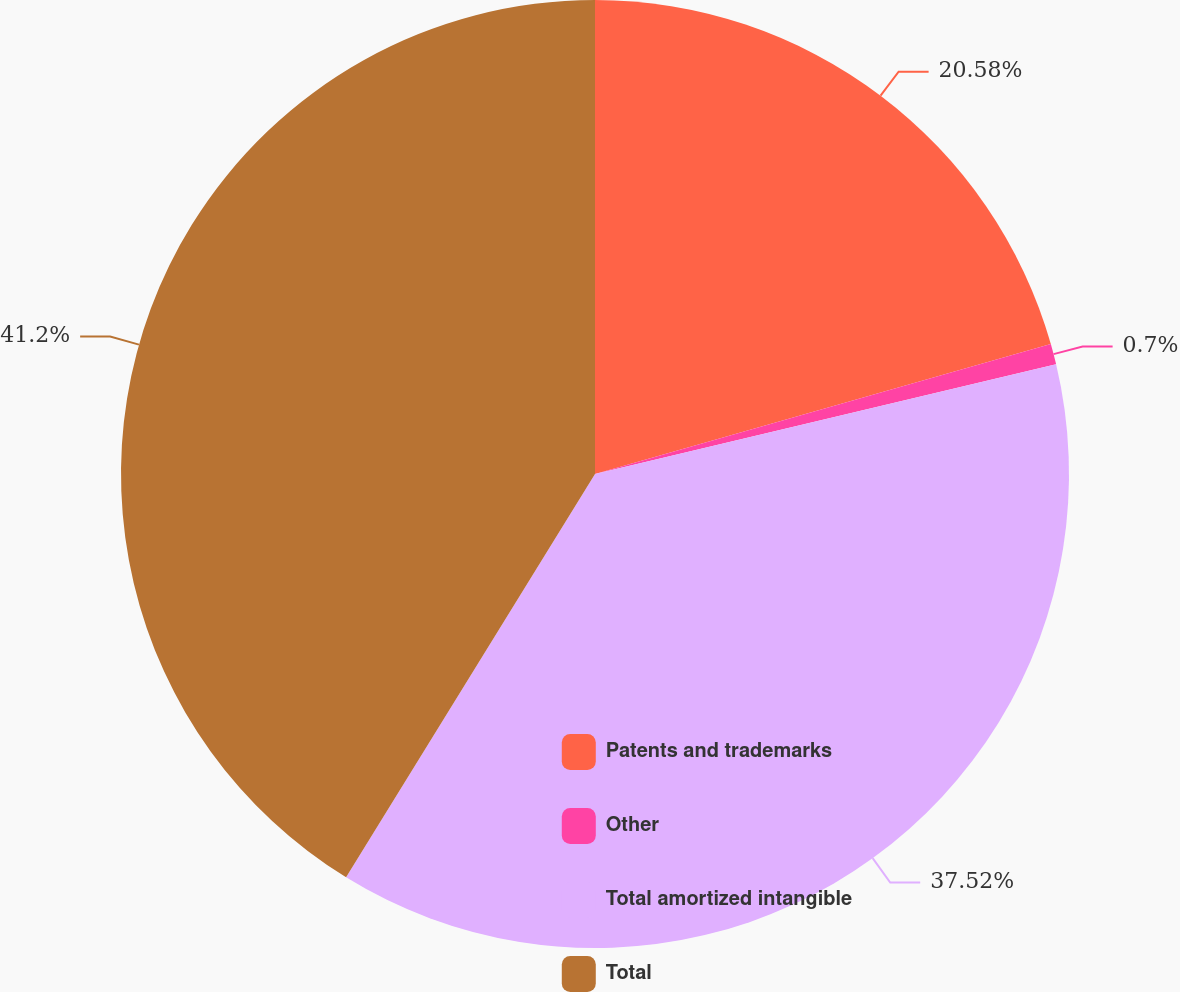Convert chart. <chart><loc_0><loc_0><loc_500><loc_500><pie_chart><fcel>Patents and trademarks<fcel>Other<fcel>Total amortized intangible<fcel>Total<nl><fcel>20.58%<fcel>0.7%<fcel>37.52%<fcel>41.2%<nl></chart> 